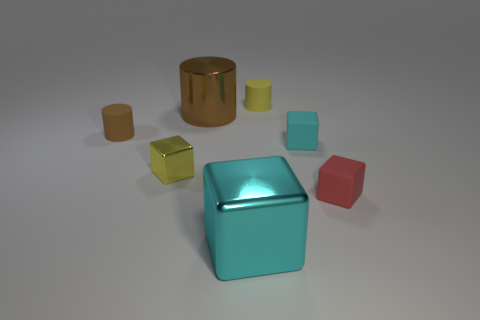There is a rubber object that is the same color as the tiny metal thing; what is its shape? cylinder 